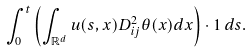Convert formula to latex. <formula><loc_0><loc_0><loc_500><loc_500>\int _ { 0 } ^ { t } \left ( \int _ { \mathbb { R } ^ { d } } u ( s , x ) D ^ { 2 } _ { i j } \theta ( x ) d x \right ) \cdot 1 \, d s .</formula> 